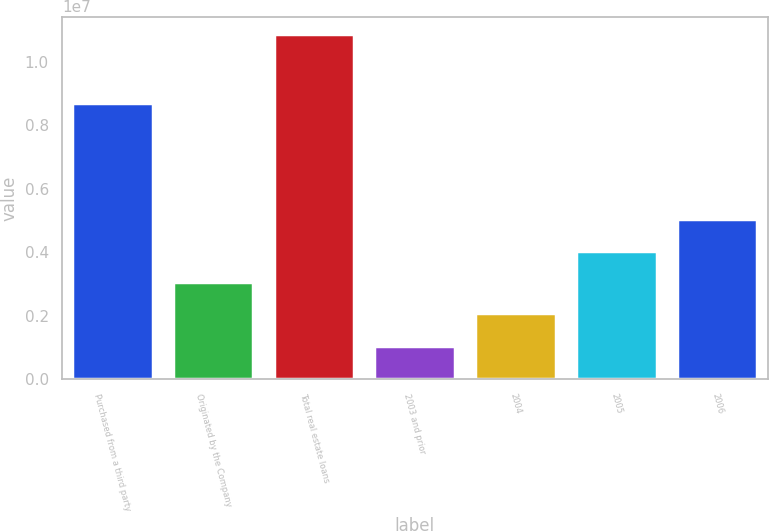Convert chart to OTSL. <chart><loc_0><loc_0><loc_500><loc_500><bar_chart><fcel>Purchased from a third party<fcel>Originated by the Company<fcel>Total real estate loans<fcel>2003 and prior<fcel>2004<fcel>2005<fcel>2006<nl><fcel>8.67957e+06<fcel>3.06347e+06<fcel>1.08702e+07<fcel>1.04422e+06<fcel>2.08087e+06<fcel>4.04607e+06<fcel>5.02867e+06<nl></chart> 